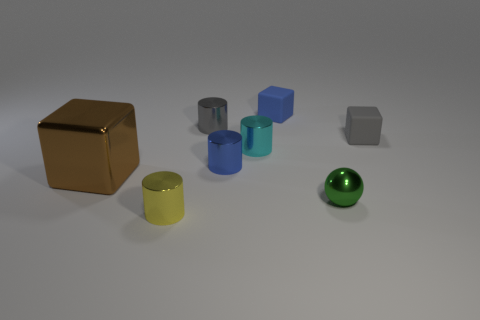Subtract all small gray cylinders. How many cylinders are left? 3 Add 1 gray matte cylinders. How many objects exist? 9 Subtract all cubes. How many objects are left? 5 Subtract 2 cylinders. How many cylinders are left? 2 Subtract all gray balls. Subtract all brown cylinders. How many balls are left? 1 Subtract all cyan cubes. How many gray cylinders are left? 1 Subtract all gray cubes. Subtract all yellow things. How many objects are left? 6 Add 1 metallic cylinders. How many metallic cylinders are left? 5 Add 1 yellow shiny cubes. How many yellow shiny cubes exist? 1 Subtract all gray cubes. How many cubes are left? 2 